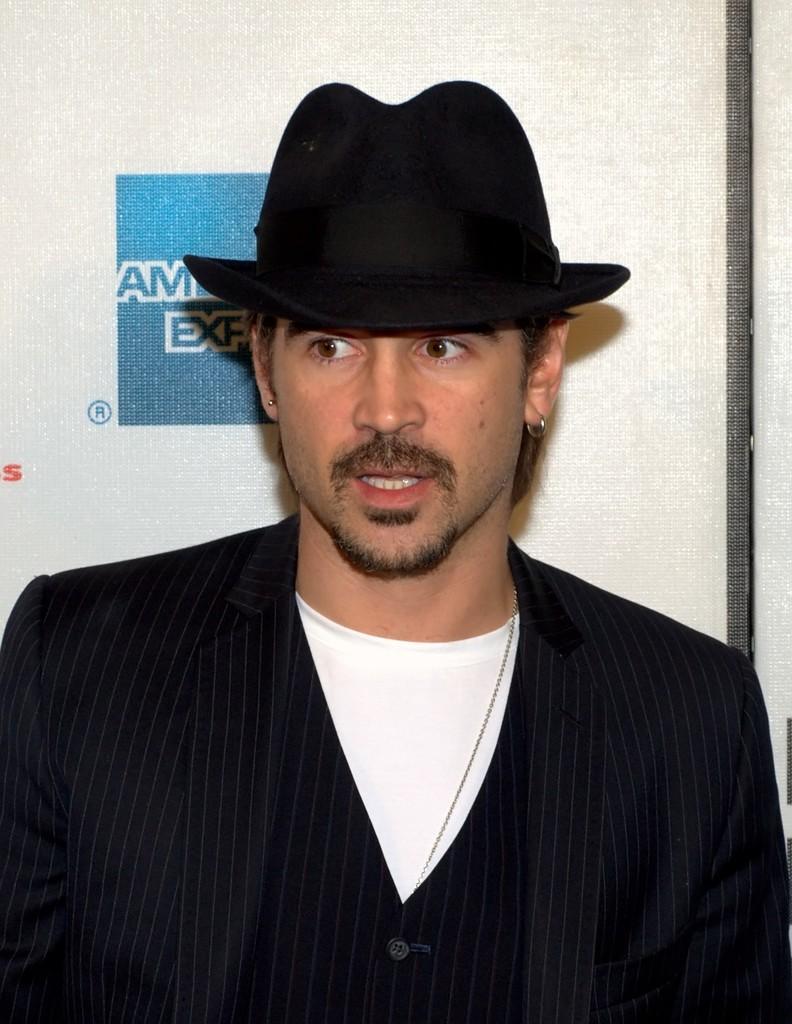How would you summarize this image in a sentence or two? In the center of the image a man is present and wearing hat and suit. In the background of the image we can see a board. 